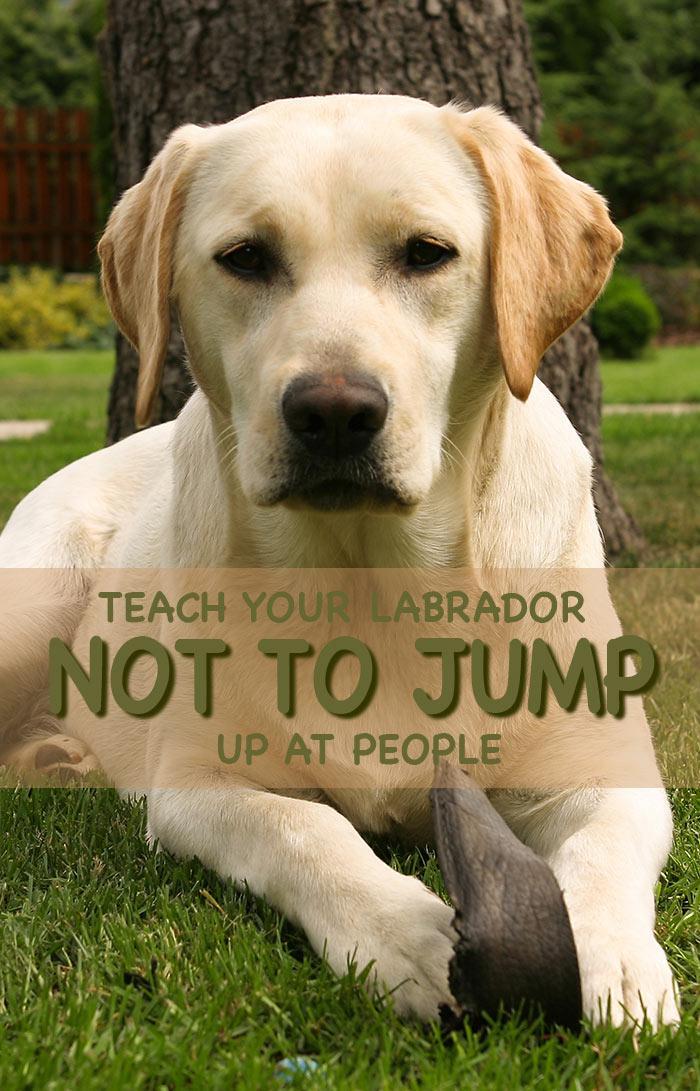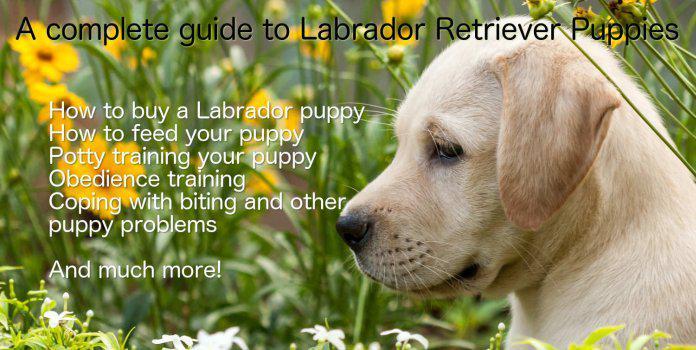The first image is the image on the left, the second image is the image on the right. Evaluate the accuracy of this statement regarding the images: "One image shows exactly two retrievers, which are side-by-side.". Is it true? Answer yes or no. No. The first image is the image on the left, the second image is the image on the right. Analyze the images presented: Is the assertion "There are two dogs" valid? Answer yes or no. Yes. 